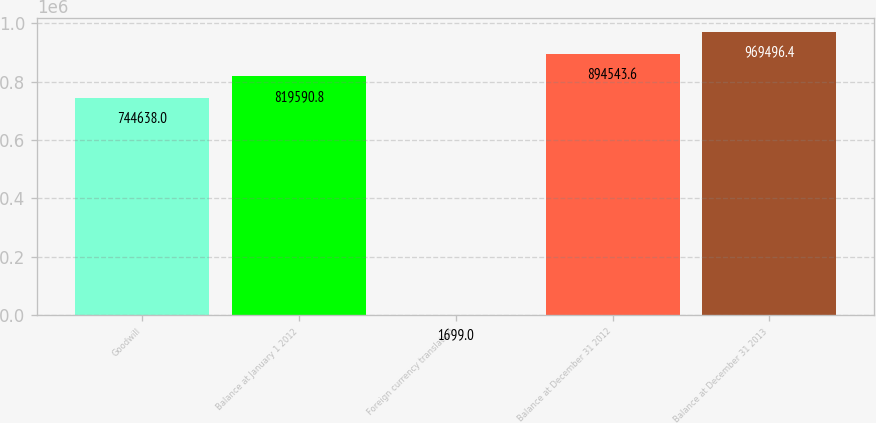Convert chart to OTSL. <chart><loc_0><loc_0><loc_500><loc_500><bar_chart><fcel>Goodwill<fcel>Balance at January 1 2012<fcel>Foreign currency translation<fcel>Balance at December 31 2012<fcel>Balance at December 31 2013<nl><fcel>744638<fcel>819591<fcel>1699<fcel>894544<fcel>969496<nl></chart> 